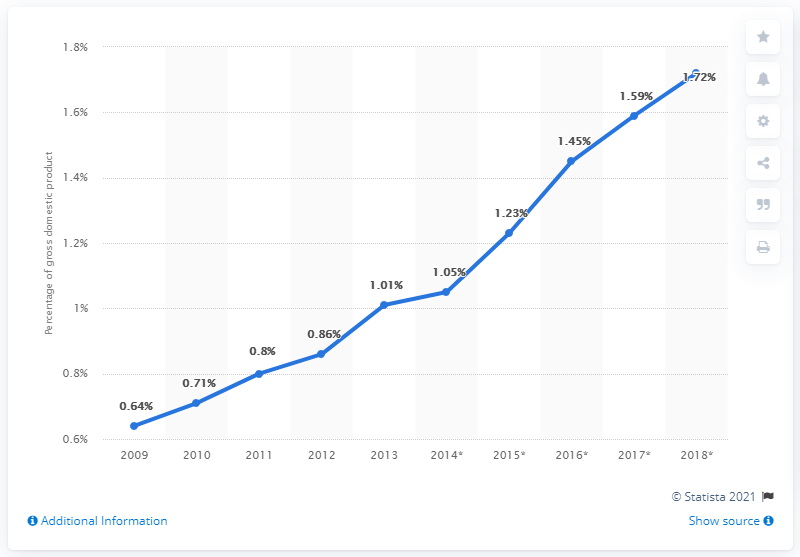List a handful of essential elements in this visual. In 2013, B2C e-commerce accounted for approximately 1.01% of Japan's GDP, a significant increase from the previous year. 